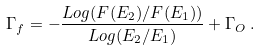<formula> <loc_0><loc_0><loc_500><loc_500>\Gamma _ { f } = - \frac { L o g ( F ( E _ { 2 } ) / F ( E _ { 1 } ) ) } { L o g ( E _ { 2 } / E _ { 1 } ) } + \Gamma _ { O } \, .</formula> 